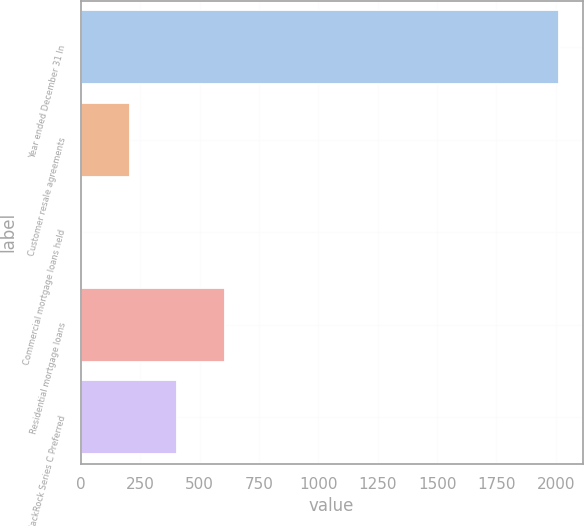Convert chart. <chart><loc_0><loc_0><loc_500><loc_500><bar_chart><fcel>Year ended December 31 In<fcel>Customer resale agreements<fcel>Commercial mortgage loans held<fcel>Residential mortgage loans<fcel>BlackRock Series C Preferred<nl><fcel>2012<fcel>205.7<fcel>5<fcel>607.1<fcel>406.4<nl></chart> 